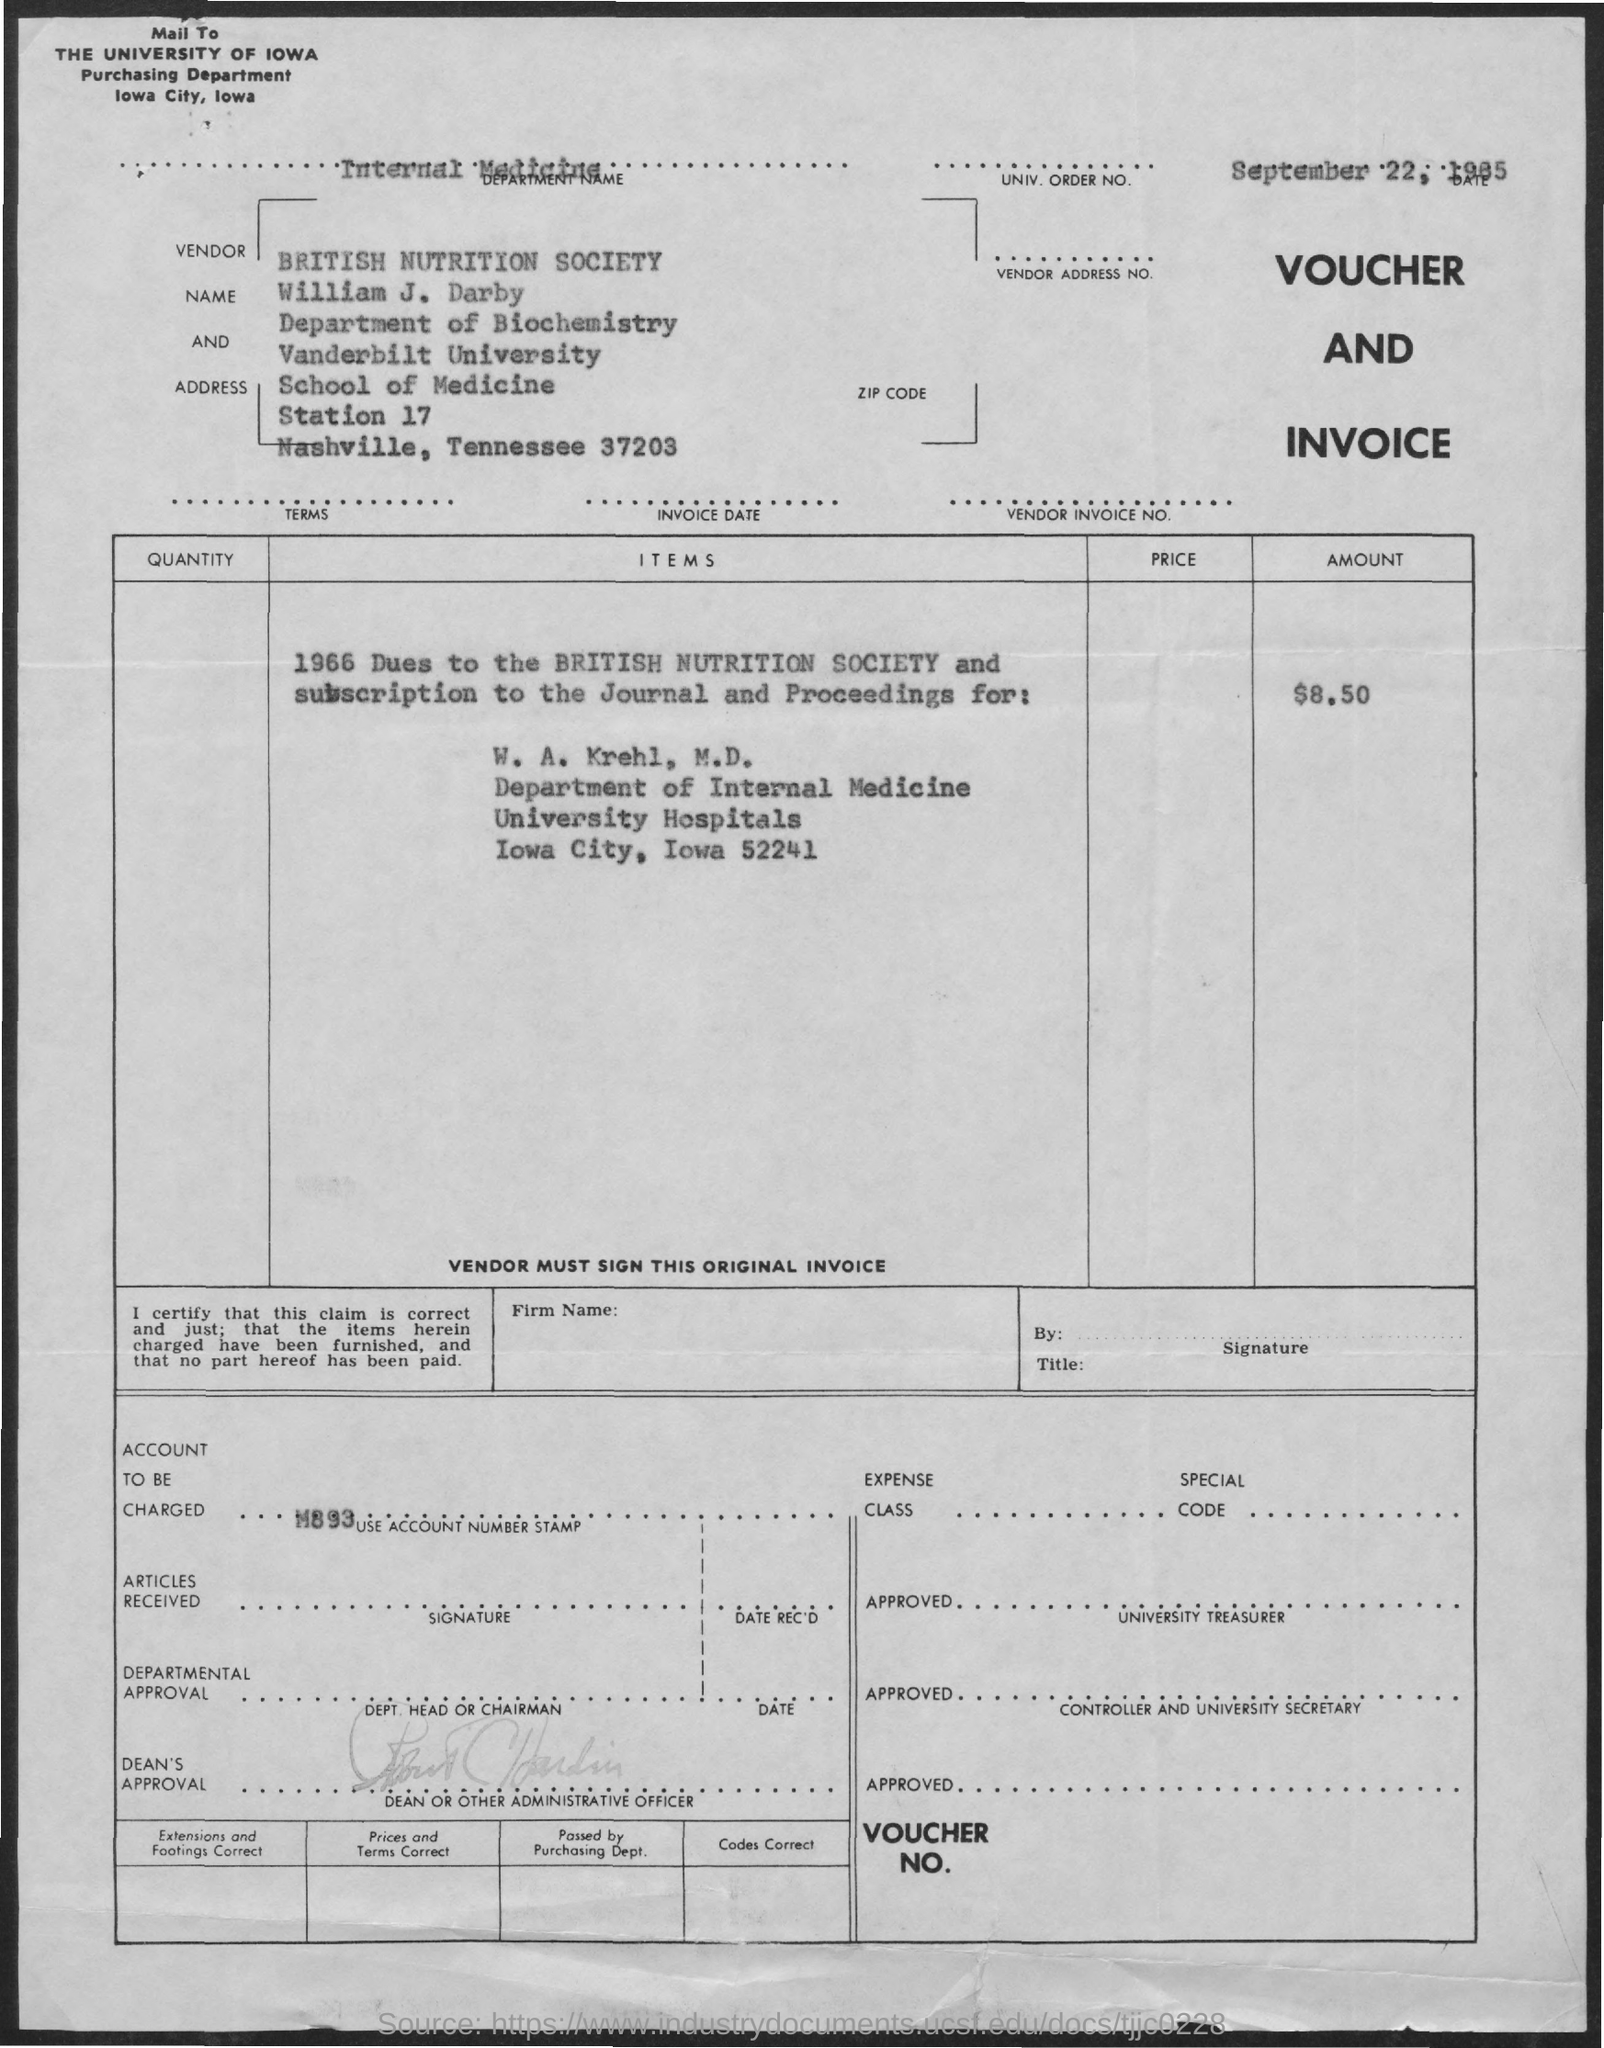Point out several critical features in this image. The department mentioned on the invoice is Internal Medicine. The invoice amount, as stated in the document, is $8.50. The voucher provides the information for the account that will be charged, specifically M893... 